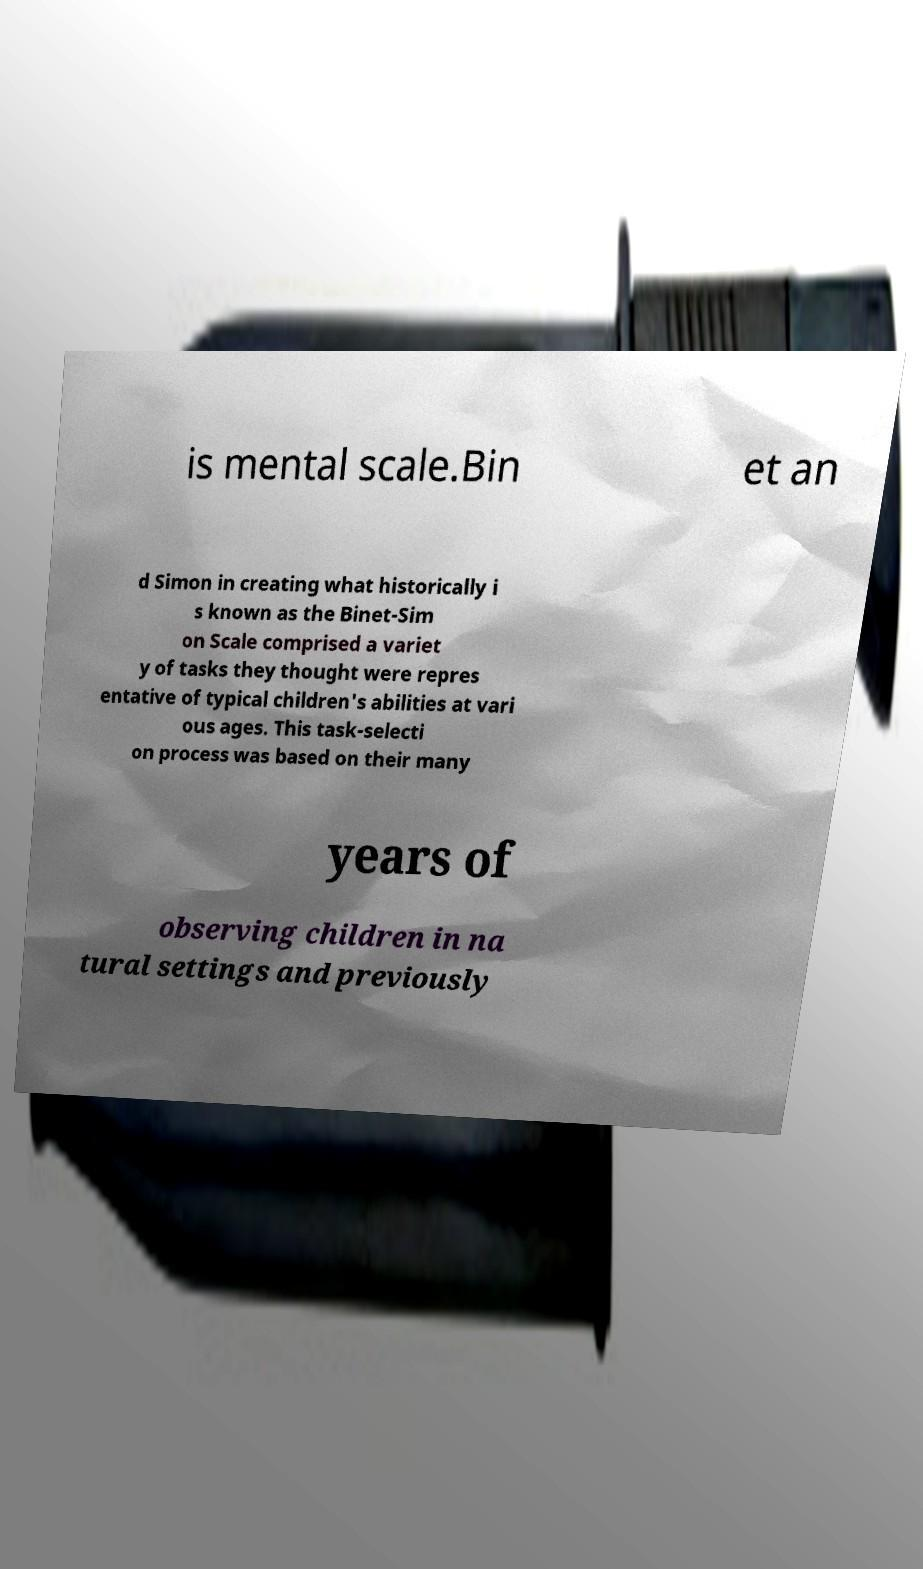Please identify and transcribe the text found in this image. is mental scale.Bin et an d Simon in creating what historically i s known as the Binet-Sim on Scale comprised a variet y of tasks they thought were repres entative of typical children's abilities at vari ous ages. This task-selecti on process was based on their many years of observing children in na tural settings and previously 